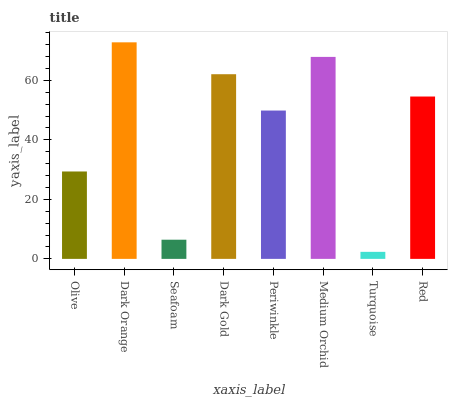Is Turquoise the minimum?
Answer yes or no. Yes. Is Dark Orange the maximum?
Answer yes or no. Yes. Is Seafoam the minimum?
Answer yes or no. No. Is Seafoam the maximum?
Answer yes or no. No. Is Dark Orange greater than Seafoam?
Answer yes or no. Yes. Is Seafoam less than Dark Orange?
Answer yes or no. Yes. Is Seafoam greater than Dark Orange?
Answer yes or no. No. Is Dark Orange less than Seafoam?
Answer yes or no. No. Is Red the high median?
Answer yes or no. Yes. Is Periwinkle the low median?
Answer yes or no. Yes. Is Medium Orchid the high median?
Answer yes or no. No. Is Olive the low median?
Answer yes or no. No. 